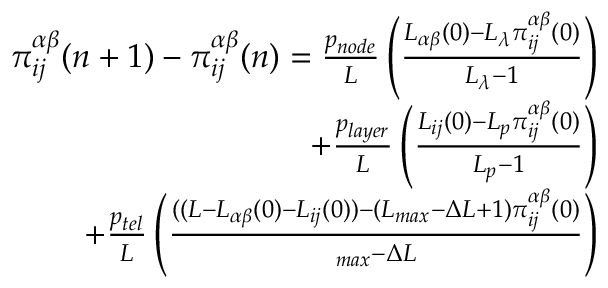<formula> <loc_0><loc_0><loc_500><loc_500>\begin{array} { r } { \pi _ { i j } ^ { \alpha \beta } ( n + 1 ) - \pi _ { i j } ^ { \alpha \beta } ( n ) = \frac { p _ { n o d e } } { L } \left ( \frac { L _ { \alpha \beta } ( 0 ) - L _ { \lambda } \pi _ { i j } ^ { \alpha \beta } ( 0 ) } { L _ { \lambda } - 1 } \right ) } \\ { + \frac { p _ { l a y e r } } { L } \left ( \frac { L _ { i j } ( 0 ) - L _ { p } \pi _ { i j } ^ { \alpha \beta } ( 0 ) } { L _ { p } - 1 } \right ) } \\ { + \frac { p _ { t e l } } { L } \left ( \frac { ( ( L - L _ { \alpha \beta } ( 0 ) - L _ { i j } ( 0 ) ) - ( L _ { \max } - \Delta L + 1 ) \pi _ { i j } ^ { \alpha \beta } ( 0 ) } { \L _ { \max } - \Delta L } \right ) } \end{array}</formula> 